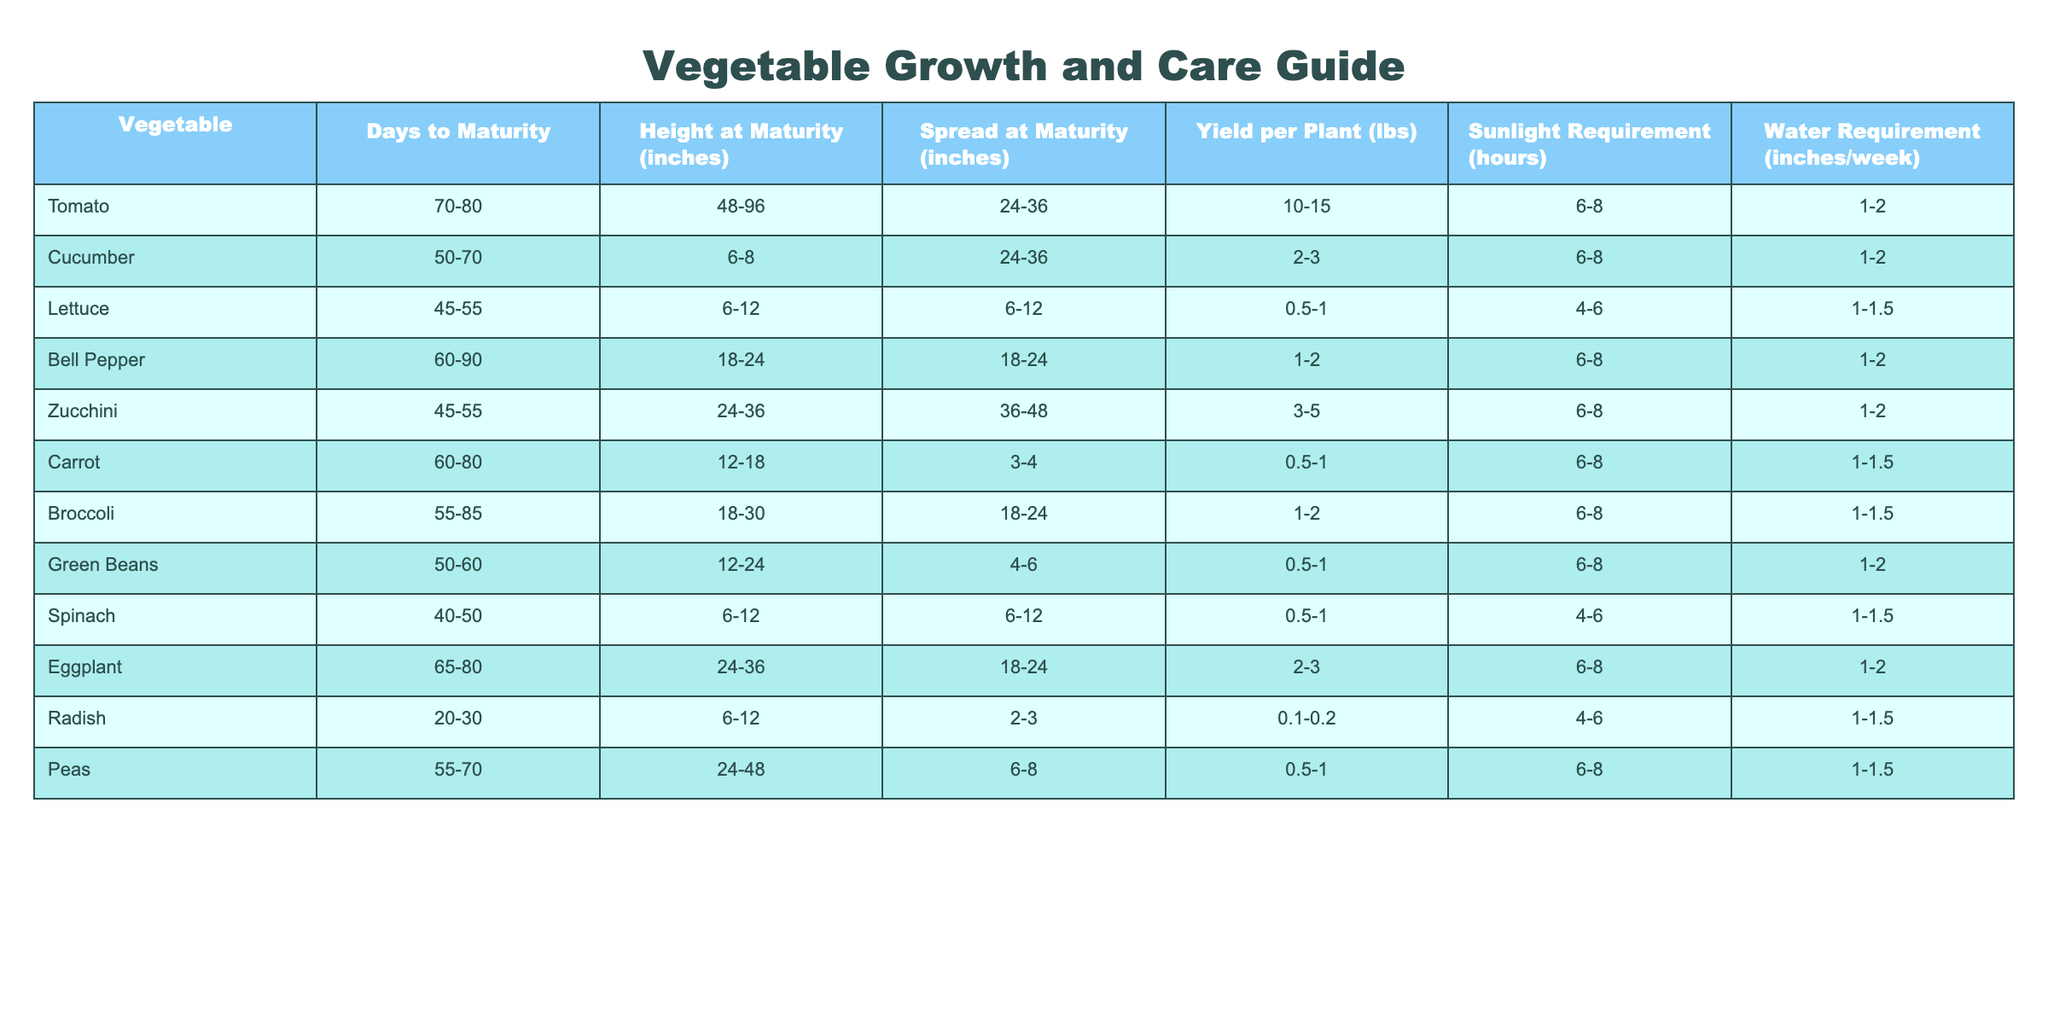What is the days to maturity for Spinach? The table lists Spinach under the vegetable category and shows that it takes 40-50 days to reach maturity.
Answer: 40-50 days Which vegetable has the largest height at maturity? By comparing the height at maturity values across all vegetables, Tomato shows the largest range of 48-96 inches at maturity.
Answer: Tomato What is the yield per plant for Zucchini? Looking at the Zucchini entry in the table, it states that the yield per plant is between 3 to 5 pounds.
Answer: 3-5 lbs True or False: Carrots require more water than Lettuce. The table indicates that Carrots need 1-1.5 inches/week of water while Lettuce needs only 1-1.5 inches/week, so the statement is false.
Answer: False What is the average yield per plant for all listed vegetables? To find the average yield per plant, sum the yields for each vegetable within their respective ranges, then divide by the number of vegetables (11). The sum is calculated as (12.5 + 4/3 + 0.75 + 1.5 + 4 + 0.75 + 0.75 + 1 + 2.5 + 0.2 + 0.75) which equals approximately 3.39 and then divided by 11 gives about 0.308 lbs.
Answer: 0.308 lbs Which vegetable has the least days to maturity, and how many days does it take? Examining the table reveals that Radish has the least days to maturity requiring only 20-30 days to mature.
Answer: Radish, 20-30 days What is the range of water requirements for Bell Pepper? The water requirement for Bell Pepper is listed under the table and shows a range of 1-2 inches/week.
Answer: 1-2 inches/week If you want to grow a vegetable with the highest spread at maturity, which one should you choose? By reviewing the spread measurements in the table, Zucchini has the highest spread range of 36-48 inches, making it the best choice.
Answer: Zucchini Which vegetables require exactly 6 hours of sunlight? Checking the sunlight requirement column, Lettuce and Spinach both require 4-6 hours while the others require 6-8 hours. Therefore, none require exactly 6 hours.
Answer: None What is the difference between the maximum and minimum height at maturity for Peas? For Peas, the height at maturity ranges from 24 to 48 inches. The difference is calculated as 48 - 24 = 24 inches.
Answer: 24 inches Which vegetable requires the most sunlight, and how many hours? Looking through the sunlight requirement column, all the vegetables require 6-8 hours, but Bell Pepper reaches up to 8. The maximum sunlight requirement is 8 hours.
Answer: 8 hours 